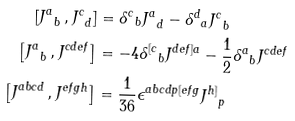Convert formula to latex. <formula><loc_0><loc_0><loc_500><loc_500>\left [ { J ^ { a } } _ { b } \, , { J ^ { c } } _ { d } \right ] & = { \delta ^ { c } } _ { b } { J ^ { a } } _ { d } - { \delta ^ { d } } _ { a } { J ^ { c } } _ { b } \\ \left [ { J ^ { a } } _ { b } \, , J ^ { c d e f } \right ] & = - 4 { \delta ^ { [ c } } _ { b } J ^ { d e f ] a } - \frac { 1 } { 2 } { \delta ^ { a } } _ { b } J ^ { c d e f } \\ \left [ J ^ { a b c d } \, , J ^ { e f g h } \right ] & = \frac { 1 } { 3 6 } \epsilon ^ { a b c d p [ e f g } { J ^ { h ] } } _ { p }</formula> 